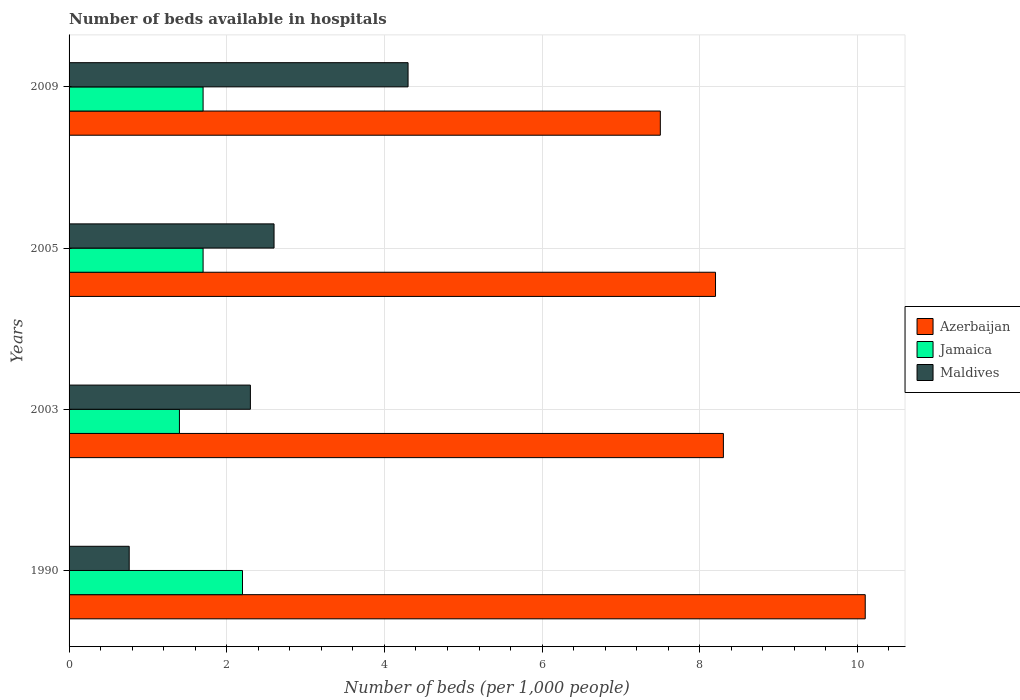How many different coloured bars are there?
Keep it short and to the point. 3. Are the number of bars on each tick of the Y-axis equal?
Make the answer very short. Yes. How many bars are there on the 1st tick from the bottom?
Make the answer very short. 3. What is the label of the 2nd group of bars from the top?
Provide a short and direct response. 2005. In how many cases, is the number of bars for a given year not equal to the number of legend labels?
Offer a very short reply. 0. What is the number of beds in the hospiatls of in Jamaica in 1990?
Offer a terse response. 2.2. In which year was the number of beds in the hospiatls of in Jamaica maximum?
Offer a terse response. 1990. In which year was the number of beds in the hospiatls of in Azerbaijan minimum?
Your answer should be very brief. 2009. What is the total number of beds in the hospiatls of in Maldives in the graph?
Your answer should be very brief. 9.96. What is the difference between the number of beds in the hospiatls of in Azerbaijan in 1990 and that in 2005?
Your response must be concise. 1.9. What is the difference between the number of beds in the hospiatls of in Jamaica in 2009 and the number of beds in the hospiatls of in Maldives in 2003?
Keep it short and to the point. -0.6. What is the average number of beds in the hospiatls of in Jamaica per year?
Offer a terse response. 1.75. In the year 2003, what is the difference between the number of beds in the hospiatls of in Jamaica and number of beds in the hospiatls of in Azerbaijan?
Offer a terse response. -6.9. In how many years, is the number of beds in the hospiatls of in Maldives greater than 6 ?
Provide a short and direct response. 0. What is the ratio of the number of beds in the hospiatls of in Jamaica in 2003 to that in 2005?
Your response must be concise. 0.82. Is the difference between the number of beds in the hospiatls of in Jamaica in 2003 and 2005 greater than the difference between the number of beds in the hospiatls of in Azerbaijan in 2003 and 2005?
Your response must be concise. No. What is the difference between the highest and the second highest number of beds in the hospiatls of in Maldives?
Offer a very short reply. 1.7. What is the difference between the highest and the lowest number of beds in the hospiatls of in Azerbaijan?
Provide a succinct answer. 2.6. In how many years, is the number of beds in the hospiatls of in Maldives greater than the average number of beds in the hospiatls of in Maldives taken over all years?
Provide a short and direct response. 2. Is the sum of the number of beds in the hospiatls of in Azerbaijan in 1990 and 2003 greater than the maximum number of beds in the hospiatls of in Maldives across all years?
Provide a succinct answer. Yes. What does the 1st bar from the top in 1990 represents?
Your answer should be very brief. Maldives. What does the 1st bar from the bottom in 2009 represents?
Provide a short and direct response. Azerbaijan. How many years are there in the graph?
Give a very brief answer. 4. What is the difference between two consecutive major ticks on the X-axis?
Your answer should be compact. 2. Are the values on the major ticks of X-axis written in scientific E-notation?
Your answer should be very brief. No. Where does the legend appear in the graph?
Keep it short and to the point. Center right. What is the title of the graph?
Offer a very short reply. Number of beds available in hospitals. Does "Tunisia" appear as one of the legend labels in the graph?
Give a very brief answer. No. What is the label or title of the X-axis?
Offer a terse response. Number of beds (per 1,0 people). What is the label or title of the Y-axis?
Ensure brevity in your answer.  Years. What is the Number of beds (per 1,000 people) in Azerbaijan in 1990?
Your response must be concise. 10.1. What is the Number of beds (per 1,000 people) of Jamaica in 1990?
Keep it short and to the point. 2.2. What is the Number of beds (per 1,000 people) of Maldives in 1990?
Offer a very short reply. 0.76. What is the Number of beds (per 1,000 people) in Azerbaijan in 2003?
Give a very brief answer. 8.3. What is the Number of beds (per 1,000 people) in Jamaica in 2003?
Offer a terse response. 1.4. What is the Number of beds (per 1,000 people) in Jamaica in 2005?
Provide a short and direct response. 1.7. What is the Number of beds (per 1,000 people) of Azerbaijan in 2009?
Keep it short and to the point. 7.5. What is the Number of beds (per 1,000 people) in Jamaica in 2009?
Your response must be concise. 1.7. What is the Number of beds (per 1,000 people) in Maldives in 2009?
Offer a very short reply. 4.3. Across all years, what is the maximum Number of beds (per 1,000 people) in Azerbaijan?
Your response must be concise. 10.1. Across all years, what is the maximum Number of beds (per 1,000 people) in Jamaica?
Provide a short and direct response. 2.2. Across all years, what is the maximum Number of beds (per 1,000 people) of Maldives?
Make the answer very short. 4.3. Across all years, what is the minimum Number of beds (per 1,000 people) of Jamaica?
Keep it short and to the point. 1.4. Across all years, what is the minimum Number of beds (per 1,000 people) in Maldives?
Provide a short and direct response. 0.76. What is the total Number of beds (per 1,000 people) of Azerbaijan in the graph?
Keep it short and to the point. 34.1. What is the total Number of beds (per 1,000 people) in Jamaica in the graph?
Provide a succinct answer. 7. What is the total Number of beds (per 1,000 people) in Maldives in the graph?
Provide a succinct answer. 9.96. What is the difference between the Number of beds (per 1,000 people) of Azerbaijan in 1990 and that in 2003?
Keep it short and to the point. 1.8. What is the difference between the Number of beds (per 1,000 people) in Maldives in 1990 and that in 2003?
Offer a very short reply. -1.54. What is the difference between the Number of beds (per 1,000 people) in Azerbaijan in 1990 and that in 2005?
Your response must be concise. 1.9. What is the difference between the Number of beds (per 1,000 people) of Jamaica in 1990 and that in 2005?
Offer a very short reply. 0.5. What is the difference between the Number of beds (per 1,000 people) of Maldives in 1990 and that in 2005?
Give a very brief answer. -1.84. What is the difference between the Number of beds (per 1,000 people) of Azerbaijan in 1990 and that in 2009?
Offer a very short reply. 2.6. What is the difference between the Number of beds (per 1,000 people) of Maldives in 1990 and that in 2009?
Your answer should be very brief. -3.54. What is the difference between the Number of beds (per 1,000 people) of Azerbaijan in 2003 and that in 2005?
Ensure brevity in your answer.  0.1. What is the difference between the Number of beds (per 1,000 people) in Azerbaijan in 2003 and that in 2009?
Your answer should be compact. 0.8. What is the difference between the Number of beds (per 1,000 people) of Jamaica in 2003 and that in 2009?
Give a very brief answer. -0.3. What is the difference between the Number of beds (per 1,000 people) in Maldives in 2003 and that in 2009?
Provide a short and direct response. -2. What is the difference between the Number of beds (per 1,000 people) of Azerbaijan in 2005 and that in 2009?
Give a very brief answer. 0.7. What is the difference between the Number of beds (per 1,000 people) of Jamaica in 2005 and that in 2009?
Make the answer very short. 0. What is the difference between the Number of beds (per 1,000 people) of Azerbaijan in 1990 and the Number of beds (per 1,000 people) of Jamaica in 2003?
Give a very brief answer. 8.7. What is the difference between the Number of beds (per 1,000 people) of Azerbaijan in 1990 and the Number of beds (per 1,000 people) of Maldives in 2003?
Offer a very short reply. 7.8. What is the difference between the Number of beds (per 1,000 people) in Jamaica in 1990 and the Number of beds (per 1,000 people) in Maldives in 2003?
Offer a very short reply. -0.1. What is the difference between the Number of beds (per 1,000 people) of Azerbaijan in 1990 and the Number of beds (per 1,000 people) of Jamaica in 2005?
Offer a very short reply. 8.4. What is the difference between the Number of beds (per 1,000 people) in Azerbaijan in 1990 and the Number of beds (per 1,000 people) in Maldives in 2005?
Your response must be concise. 7.5. What is the difference between the Number of beds (per 1,000 people) of Jamaica in 1990 and the Number of beds (per 1,000 people) of Maldives in 2005?
Give a very brief answer. -0.4. What is the difference between the Number of beds (per 1,000 people) in Azerbaijan in 1990 and the Number of beds (per 1,000 people) in Jamaica in 2009?
Your answer should be compact. 8.4. What is the difference between the Number of beds (per 1,000 people) in Azerbaijan in 1990 and the Number of beds (per 1,000 people) in Maldives in 2009?
Provide a short and direct response. 5.8. What is the difference between the Number of beds (per 1,000 people) of Jamaica in 1990 and the Number of beds (per 1,000 people) of Maldives in 2009?
Make the answer very short. -2.1. What is the difference between the Number of beds (per 1,000 people) of Azerbaijan in 2003 and the Number of beds (per 1,000 people) of Jamaica in 2005?
Your answer should be very brief. 6.6. What is the difference between the Number of beds (per 1,000 people) of Azerbaijan in 2003 and the Number of beds (per 1,000 people) of Jamaica in 2009?
Your answer should be compact. 6.6. What is the difference between the Number of beds (per 1,000 people) of Jamaica in 2003 and the Number of beds (per 1,000 people) of Maldives in 2009?
Make the answer very short. -2.9. What is the difference between the Number of beds (per 1,000 people) of Azerbaijan in 2005 and the Number of beds (per 1,000 people) of Jamaica in 2009?
Your answer should be compact. 6.5. What is the difference between the Number of beds (per 1,000 people) of Jamaica in 2005 and the Number of beds (per 1,000 people) of Maldives in 2009?
Give a very brief answer. -2.6. What is the average Number of beds (per 1,000 people) in Azerbaijan per year?
Ensure brevity in your answer.  8.52. What is the average Number of beds (per 1,000 people) of Jamaica per year?
Your response must be concise. 1.75. What is the average Number of beds (per 1,000 people) in Maldives per year?
Offer a very short reply. 2.49. In the year 1990, what is the difference between the Number of beds (per 1,000 people) of Azerbaijan and Number of beds (per 1,000 people) of Jamaica?
Your response must be concise. 7.9. In the year 1990, what is the difference between the Number of beds (per 1,000 people) in Azerbaijan and Number of beds (per 1,000 people) in Maldives?
Offer a terse response. 9.34. In the year 1990, what is the difference between the Number of beds (per 1,000 people) of Jamaica and Number of beds (per 1,000 people) of Maldives?
Provide a succinct answer. 1.44. In the year 2003, what is the difference between the Number of beds (per 1,000 people) of Azerbaijan and Number of beds (per 1,000 people) of Maldives?
Your answer should be compact. 6. In the year 2003, what is the difference between the Number of beds (per 1,000 people) of Jamaica and Number of beds (per 1,000 people) of Maldives?
Provide a short and direct response. -0.9. In the year 2005, what is the difference between the Number of beds (per 1,000 people) of Azerbaijan and Number of beds (per 1,000 people) of Jamaica?
Make the answer very short. 6.5. What is the ratio of the Number of beds (per 1,000 people) in Azerbaijan in 1990 to that in 2003?
Provide a succinct answer. 1.22. What is the ratio of the Number of beds (per 1,000 people) in Jamaica in 1990 to that in 2003?
Ensure brevity in your answer.  1.57. What is the ratio of the Number of beds (per 1,000 people) of Maldives in 1990 to that in 2003?
Keep it short and to the point. 0.33. What is the ratio of the Number of beds (per 1,000 people) in Azerbaijan in 1990 to that in 2005?
Keep it short and to the point. 1.23. What is the ratio of the Number of beds (per 1,000 people) in Jamaica in 1990 to that in 2005?
Offer a very short reply. 1.29. What is the ratio of the Number of beds (per 1,000 people) in Maldives in 1990 to that in 2005?
Your response must be concise. 0.29. What is the ratio of the Number of beds (per 1,000 people) in Azerbaijan in 1990 to that in 2009?
Your response must be concise. 1.35. What is the ratio of the Number of beds (per 1,000 people) in Jamaica in 1990 to that in 2009?
Make the answer very short. 1.29. What is the ratio of the Number of beds (per 1,000 people) of Maldives in 1990 to that in 2009?
Keep it short and to the point. 0.18. What is the ratio of the Number of beds (per 1,000 people) of Azerbaijan in 2003 to that in 2005?
Make the answer very short. 1.01. What is the ratio of the Number of beds (per 1,000 people) in Jamaica in 2003 to that in 2005?
Give a very brief answer. 0.82. What is the ratio of the Number of beds (per 1,000 people) of Maldives in 2003 to that in 2005?
Make the answer very short. 0.88. What is the ratio of the Number of beds (per 1,000 people) of Azerbaijan in 2003 to that in 2009?
Make the answer very short. 1.11. What is the ratio of the Number of beds (per 1,000 people) of Jamaica in 2003 to that in 2009?
Ensure brevity in your answer.  0.82. What is the ratio of the Number of beds (per 1,000 people) of Maldives in 2003 to that in 2009?
Ensure brevity in your answer.  0.53. What is the ratio of the Number of beds (per 1,000 people) in Azerbaijan in 2005 to that in 2009?
Keep it short and to the point. 1.09. What is the ratio of the Number of beds (per 1,000 people) in Maldives in 2005 to that in 2009?
Keep it short and to the point. 0.6. What is the difference between the highest and the second highest Number of beds (per 1,000 people) in Azerbaijan?
Provide a short and direct response. 1.8. What is the difference between the highest and the second highest Number of beds (per 1,000 people) of Jamaica?
Keep it short and to the point. 0.5. What is the difference between the highest and the lowest Number of beds (per 1,000 people) of Azerbaijan?
Keep it short and to the point. 2.6. What is the difference between the highest and the lowest Number of beds (per 1,000 people) in Jamaica?
Offer a terse response. 0.8. What is the difference between the highest and the lowest Number of beds (per 1,000 people) in Maldives?
Your response must be concise. 3.54. 